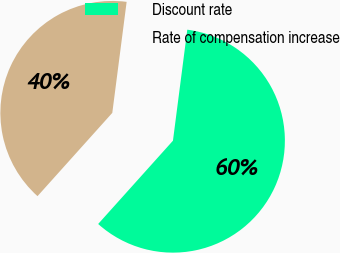<chart> <loc_0><loc_0><loc_500><loc_500><pie_chart><fcel>Discount rate<fcel>Rate of compensation increase<nl><fcel>59.6%<fcel>40.4%<nl></chart> 